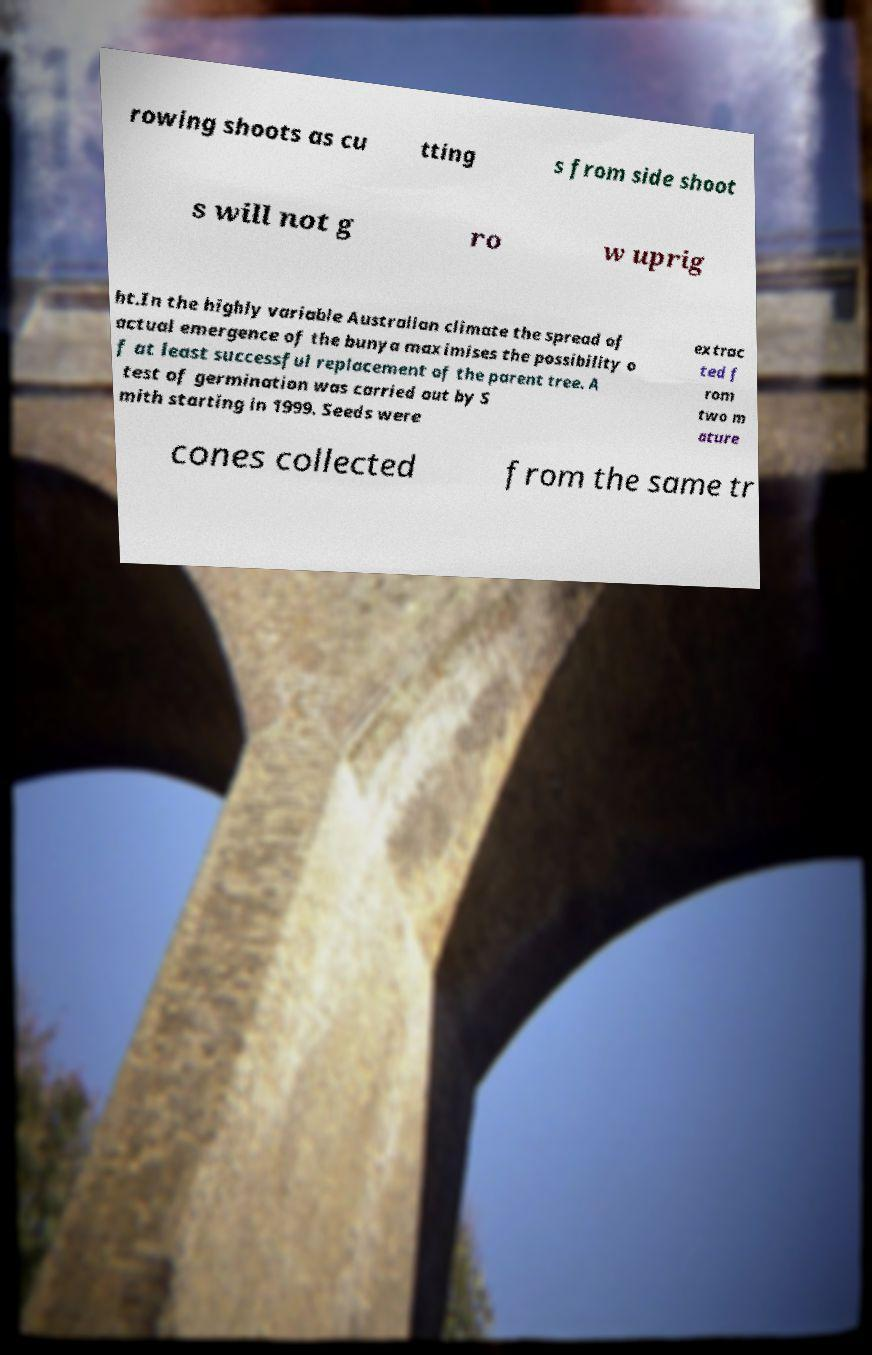I need the written content from this picture converted into text. Can you do that? rowing shoots as cu tting s from side shoot s will not g ro w uprig ht.In the highly variable Australian climate the spread of actual emergence of the bunya maximises the possibility o f at least successful replacement of the parent tree. A test of germination was carried out by S mith starting in 1999. Seeds were extrac ted f rom two m ature cones collected from the same tr 